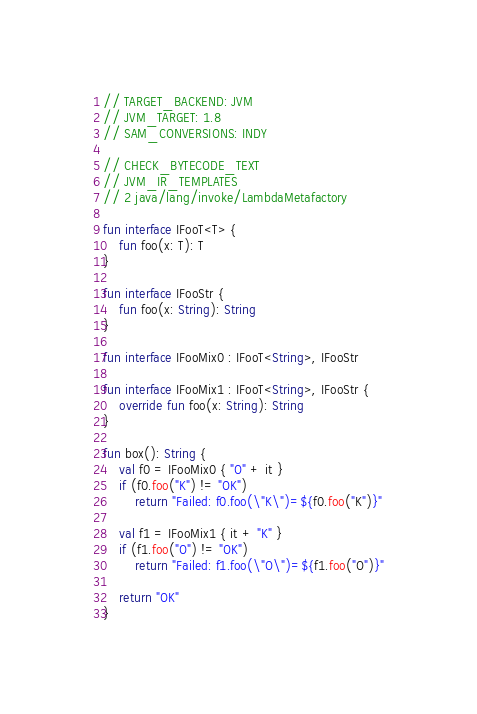Convert code to text. <code><loc_0><loc_0><loc_500><loc_500><_Kotlin_>// TARGET_BACKEND: JVM
// JVM_TARGET: 1.8
// SAM_CONVERSIONS: INDY

// CHECK_BYTECODE_TEXT
// JVM_IR_TEMPLATES
// 2 java/lang/invoke/LambdaMetafactory

fun interface IFooT<T> {
    fun foo(x: T): T
}

fun interface IFooStr {
    fun foo(x: String): String
}

fun interface IFooMix0 : IFooT<String>, IFooStr

fun interface IFooMix1 : IFooT<String>, IFooStr {
    override fun foo(x: String): String
}

fun box(): String {
    val f0 = IFooMix0 { "O" + it }
    if (f0.foo("K") != "OK")
        return "Failed: f0.foo(\"K\")=${f0.foo("K")}"

    val f1 = IFooMix1 { it + "K" }
    if (f1.foo("O") != "OK")
        return "Failed: f1.foo(\"O\")=${f1.foo("O")}"

    return "OK"
}</code> 